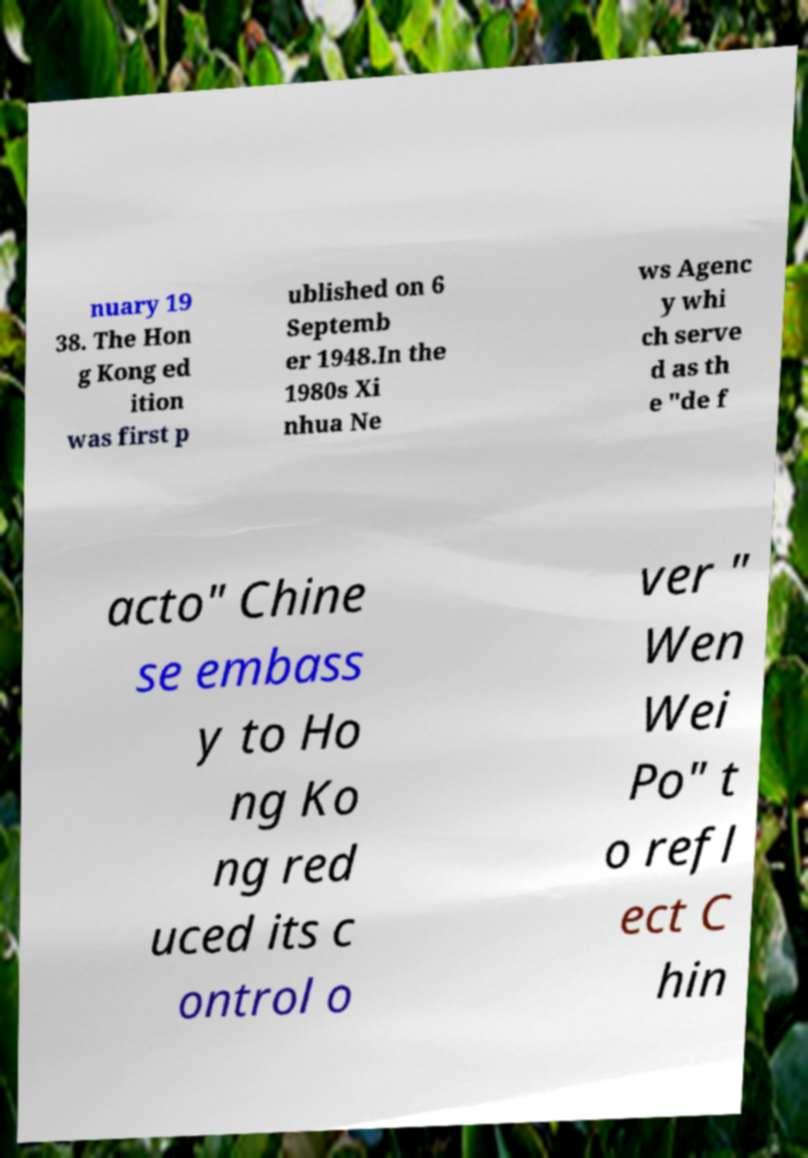Please read and relay the text visible in this image. What does it say? nuary 19 38. The Hon g Kong ed ition was first p ublished on 6 Septemb er 1948.In the 1980s Xi nhua Ne ws Agenc y whi ch serve d as th e "de f acto" Chine se embass y to Ho ng Ko ng red uced its c ontrol o ver " Wen Wei Po" t o refl ect C hin 